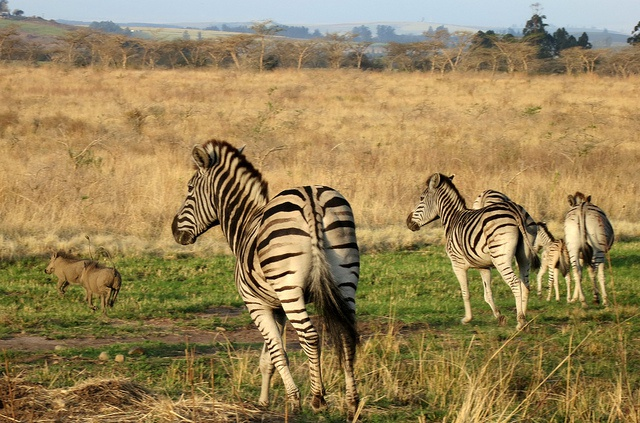Describe the objects in this image and their specific colors. I can see zebra in darkgray, black, tan, and olive tones, zebra in darkgray, tan, black, and olive tones, zebra in darkgray, olive, khaki, tan, and black tones, zebra in darkgray, tan, and olive tones, and zebra in darkgray, tan, and black tones in this image. 